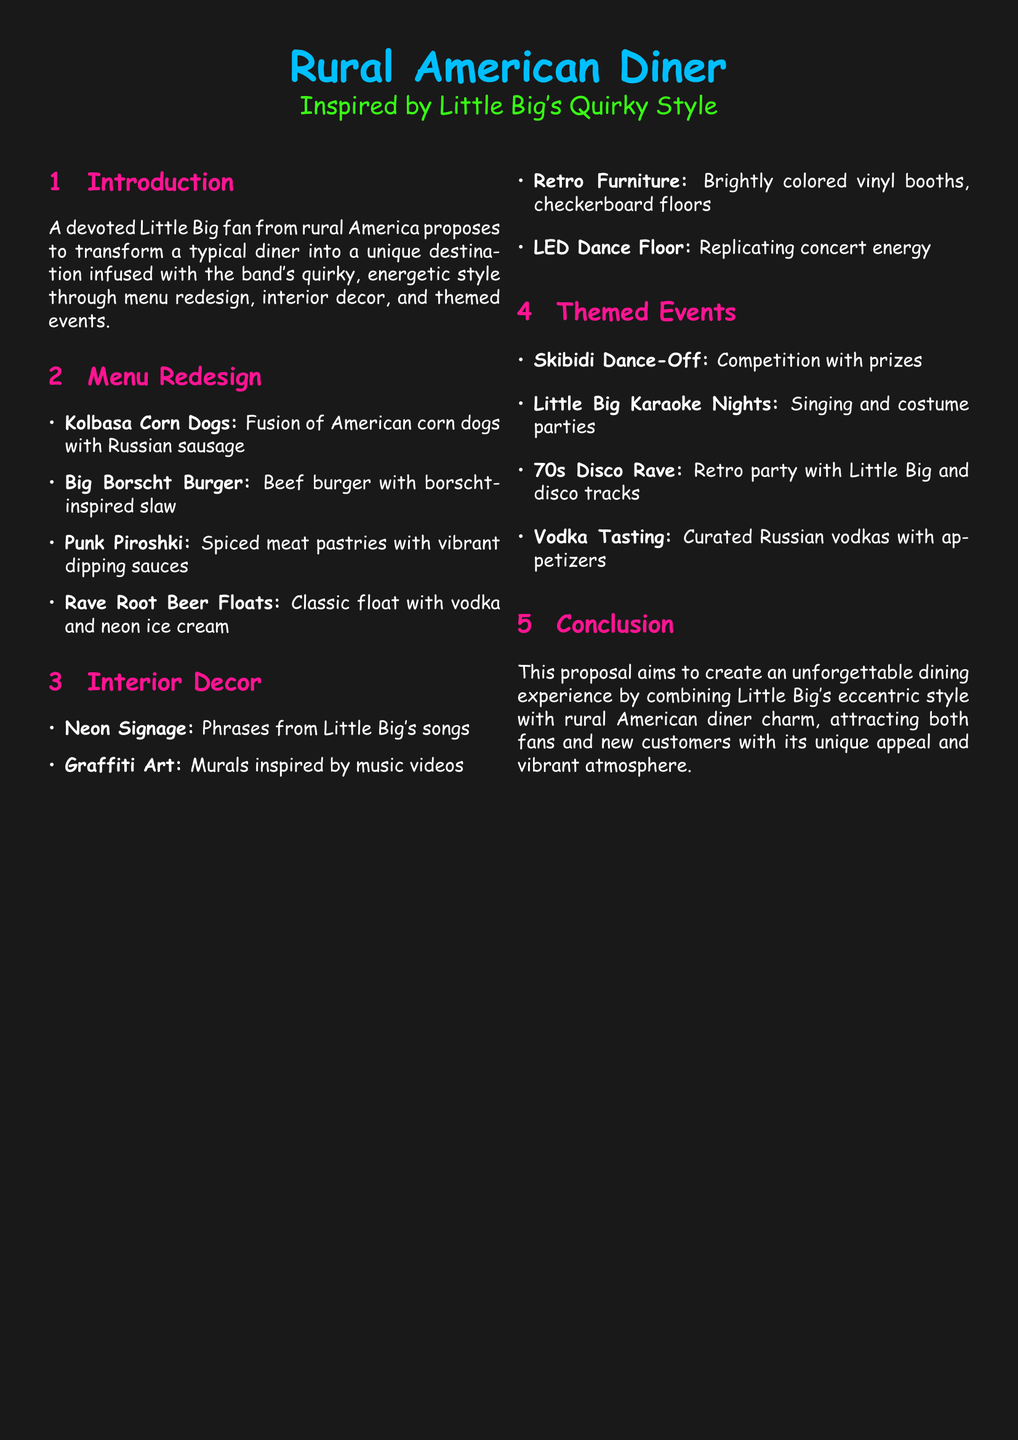What is the name of the proposal? The proposal is titled "Proposal for Customizing Rural American Diner Inspired by Little Big's Quirky Style."
Answer: Proposal for Customizing Rural American Diner Inspired by Little Big's Quirky Style What is one item on the redesigned menu? The document lists items such as "Kolbasa Corn Dogs," which is a fusion dish.
Answer: Kolbasa Corn Dogs How many themed events are proposed? There are four themed events listed in the document.
Answer: Four What type of furniture is included in the interior decor? The proposal mentions "Retro Furniture" as part of the decor.
Answer: Retro Furniture What color are the headers in the document? The headers are described as being colored neon pink.
Answer: Neon pink What is a unique feature of the decor? The LED Dance Floor replicates concert energy, which is a standout feature.
Answer: LED Dance Floor What is the purpose of the proposal? The aim is to create an unforgettable dining experience by combining different styles.
Answer: To create an unforgettable dining experience What drink is included in the redesigned menu? One of the drinks mentioned is "Rave Root Beer Floats."
Answer: Rave Root Beer Floats What phrase describes the competition event? The event is called "Skibidi Dance-Off."
Answer: Skibidi Dance-Off 